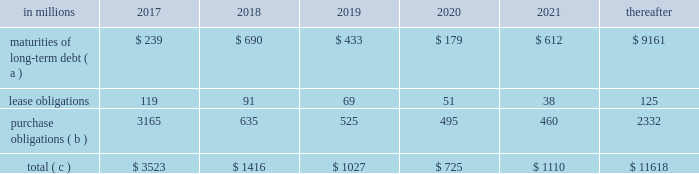Ilim holding s.a .
Shareholder 2019s agreement in october 2007 , in connection with the formation of the ilim holding s.a .
Joint venture , international paper entered into a shareholder 2019s agreement that includes provisions relating to the reconciliation of disputes among the partners .
This agreement provides that at any time , either the company or its partners may commence procedures specified under the deadlock agreement .
If these or any other deadlock procedures under the shareholder's agreement are commenced , although it is not obligated to do so , the company may in certain situations choose to purchase its partners' 50% ( 50 % ) interest in ilim .
Any such transaction would be subject to review and approval by russian and other relevant anti-trust authorities .
Based on the provisions of the agreement , the company estimates that the current purchase price for its partners' 50% ( 50 % ) interests would be approximately $ 1.5 billion , which could be satisfied by payment of cash or international paper common stock , or some combination of the two , at the company's option .
The purchase by the company of its partners 2019 50% ( 50 % ) interest in ilim would result in the consolidation of ilim's financial position and results of operations in all subsequent periods .
The parties have informed each other that they have no current intention to commence procedures specified under the deadlock provisions of the shareholder 2019s agreement .
Critical accounting policies and significant accounting estimates the preparation of financial statements in conformity with accounting principles generally accepted in the united states requires international paper to establish accounting policies and to make estimates that affect both the amounts and timing of the recording of assets , liabilities , revenues and expenses .
Some of these estimates require judgments about matters that are inherently uncertain .
Accounting policies whose application may have a significant effect on the reported results of operations and financial position of international paper , and that can require judgments by management that affect their application , include the accounting for contingencies , impairment or disposal of long-lived assets and goodwill , pensions and postretirement benefit obligations , stock options and income taxes .
The company has discussed the selection of critical accounting policies and the effect of significant estimates with the audit and finance committee of the company 2019s board of directors .
Contingent liabilities accruals for contingent liabilities , including legal and environmental matters , are recorded when it is probable that a liability has been incurred or an asset impaired and the amount of the loss can be reasonably estimated .
Liabilities accrued for legal matters require judgments regarding projected outcomes and range of loss based on historical experience and recommendations of legal counsel .
Liabilities for environmental matters require evaluations of relevant environmental regulations and estimates of future remediation alternatives and costs .
Impairment of long-lived assets and goodwill an impairment of a long-lived asset exists when the asset 2019s carrying amount exceeds its fair value , and is recorded when the carrying amount is not recoverable through cash flows from future operations .
A goodwill impairment exists when the carrying amount of goodwill exceeds its fair value .
Assessments of possible impairments of long-lived assets and goodwill are made when events or changes in circumstances indicate that the carrying value of the asset may not be recoverable through future operations .
Additionally , testing for possible impairment of goodwill and intangible asset balances is required annually .
The amount and timing of any impairment charges based on these assessments require the estimation of future cash flows and the fair market value of the related assets based on management 2019s best estimates of certain key factors , including future selling prices and volumes , operating , raw material , energy and freight costs , and various other projected operating economic factors .
As these key factors change in future periods , the company will update its impairment analyses to reflect its latest estimates and projections .
Under the provisions of accounting standards codification ( asc ) 350 , 201cintangibles 2013 goodwill and other , 201d the testing of goodwill for possible impairment is a two-step process .
In the first step , the fair value of the company 2019s reporting units is compared with their carrying value , including goodwill .
If fair value exceeds the carrying value , goodwill is not considered to be impaired .
If the fair value of a reporting unit is below the carrying value , then step two is performed to measure the amount of the goodwill impairment loss for the reporting unit .
This analysis requires the determination of the fair value of all of the individual assets and liabilities of the reporting unit , including any currently unrecognized intangible assets , as if the reporting unit had been purchased on the analysis date .
Once these fair values have been determined , the implied fair value of the unit 2019s goodwill is calculated as the excess , if any , of the fair value of the reporting unit determined in step one over the fair value of the net assets determined in step two .
The carrying value of goodwill is then reduced to this implied value , or to zero if the fair value of the assets exceeds the fair value of the reporting unit , through a goodwill impairment charge .
The impairment analysis requires a number of judgments by management .
In calculating the estimated fair value of its reporting units in step one , a total debt-to-capital ratio of less than 60% ( 60 % ) .
Net worth is defined as the sum of common stock , paid-in capital and retained earnings , less treasury stock plus any cumulative goodwill impairment charges .
The calculation also excludes accumulated other comprehensive income/loss and nonrecourse financial liabilities of special purpose entities .
The total debt-to-capital ratio is defined as total debt divided by the sum of total debt plus net worth .
The company was in compliance with all its debt covenants at december 31 , 2016 and was well below the thresholds stipulated under the covenants as defined in the credit agreements .
The company will continue to rely upon debt and capital markets for the majority of any necessary long-term funding not provided by operating cash flows .
Funding decisions will be guided by our capital structure planning objectives .
The primary goals of the company 2019s capital structure planning are to maximize financial flexibility and preserve liquidity while reducing interest expense .
The majority of international paper 2019s debt is accessed through global public capital markets where we have a wide base of investors .
Maintaining an investment grade credit rating is an important element of international paper 2019s financing strategy .
At december 31 , 2016 , the company held long-term credit ratings of bbb ( stable outlook ) and baa2 ( stable outlook ) by s&p and moody 2019s , respectively .
Contractual obligations for future payments under existing debt and lease commitments and purchase obligations at december 31 , 2016 , were as follows: .
( a ) total debt includes scheduled principal payments only .
( b ) includes $ 2 billion relating to fiber supply agreements entered into at the time of the 2006 transformation plan forestland sales and in conjunction with the 2008 acquisition of weyerhaeuser company 2019s containerboard , packaging and recycling business .
Also includes $ 1.1 billion relating to fiber supply agreements assumed in conjunction with the 2016 acquisition of weyerhaeuser's pulp business .
( c ) not included in the above table due to the uncertainty as to the amount and timing of the payment are unrecognized tax benefits of approximately $ 77 million .
We consider the undistributed earnings of our foreign subsidiaries as of december 31 , 2016 , to be indefinitely reinvested and , accordingly , no u.s .
Income taxes have been provided thereon .
As of december 31 , 2016 , the amount of cash associated with indefinitely reinvested foreign earnings was approximately $ 620 million .
We do not anticipate the need to repatriate funds to the united states to satisfy domestic liquidity needs arising in the ordinary course of business , including liquidity needs associated with our domestic debt service requirements .
Pension obligations and funding at december 31 , 2016 , the projected benefit obligation for the company 2019s u.s .
Defined benefit plans determined under u.s .
Gaap was approximately $ 3.4 billion higher than the fair value of plan assets .
Approximately $ 3.0 billion of this amount relates to plans that are subject to minimum funding requirements .
Under current irs funding rules , the calculation of minimum funding requirements differs from the calculation of the present value of plan benefits ( the projected benefit obligation ) for accounting purposes .
In december 2008 , the worker , retiree and employer recovery act of 2008 ( wera ) was passed by the u.s .
Congress which provided for pension funding relief and technical corrections .
Funding contributions depend on the funding method selected by the company , and the timing of its implementation , as well as on actual demographic data and the targeted funding level .
The company continually reassesses the amount and timing of any discretionary contributions and elected to make contributions totaling $ 750 million for both years ended december 31 , 2016 and 2015 .
At this time , we do not expect to have any required contributions to our plans in 2017 , although the company may elect to make future voluntary contributions .
The timing and amount of future contributions , which could be material , will depend on a number of factors , including the actual earnings and changes in values of plan assets and changes in interest rates .
International paper announced a voluntary , limited-time opportunity for former employees who are participants in the retirement plan of international paper company ( the pension plan ) to request early payment of their entire pension plan benefit in the form of a single lump sum payment .
The amount of total payments under this program was approximately $ 1.2 billion , and were made from plan trust assets on june 30 , 2016 .
Based on the level of payments made , settlement accounting rules applied and resulted in a plan remeasurement as of the june 30 , 2016 payment date .
As a result of settlement accounting , the company recognized a pro-rata portion of the unamortized net actuarial loss , after remeasurement , resulting in a $ 439 million non-cash charge to the company's earnings in the second quarter of 2016 .
Additional payments of $ 8 million and $ 9 million were made during the third and fourth quarters , respectively , due to mandatory cash payouts and a small lump sum payout , and the pension plan was subsequently remeasured at september 30 , 2016 and december 31 , 2016 .
As a result of settlement accounting , the company recognized non-cash settlement charges of $ 3 million in both the third and fourth quarters of 2016. .
In 2017 what percentage of contractual obligations for future payments under existing debt and lease commitments and purchase obligations at december 31 , 2016 is due to maturities of long-term debt? 
Computations: (239 / 3523)
Answer: 0.06784. 